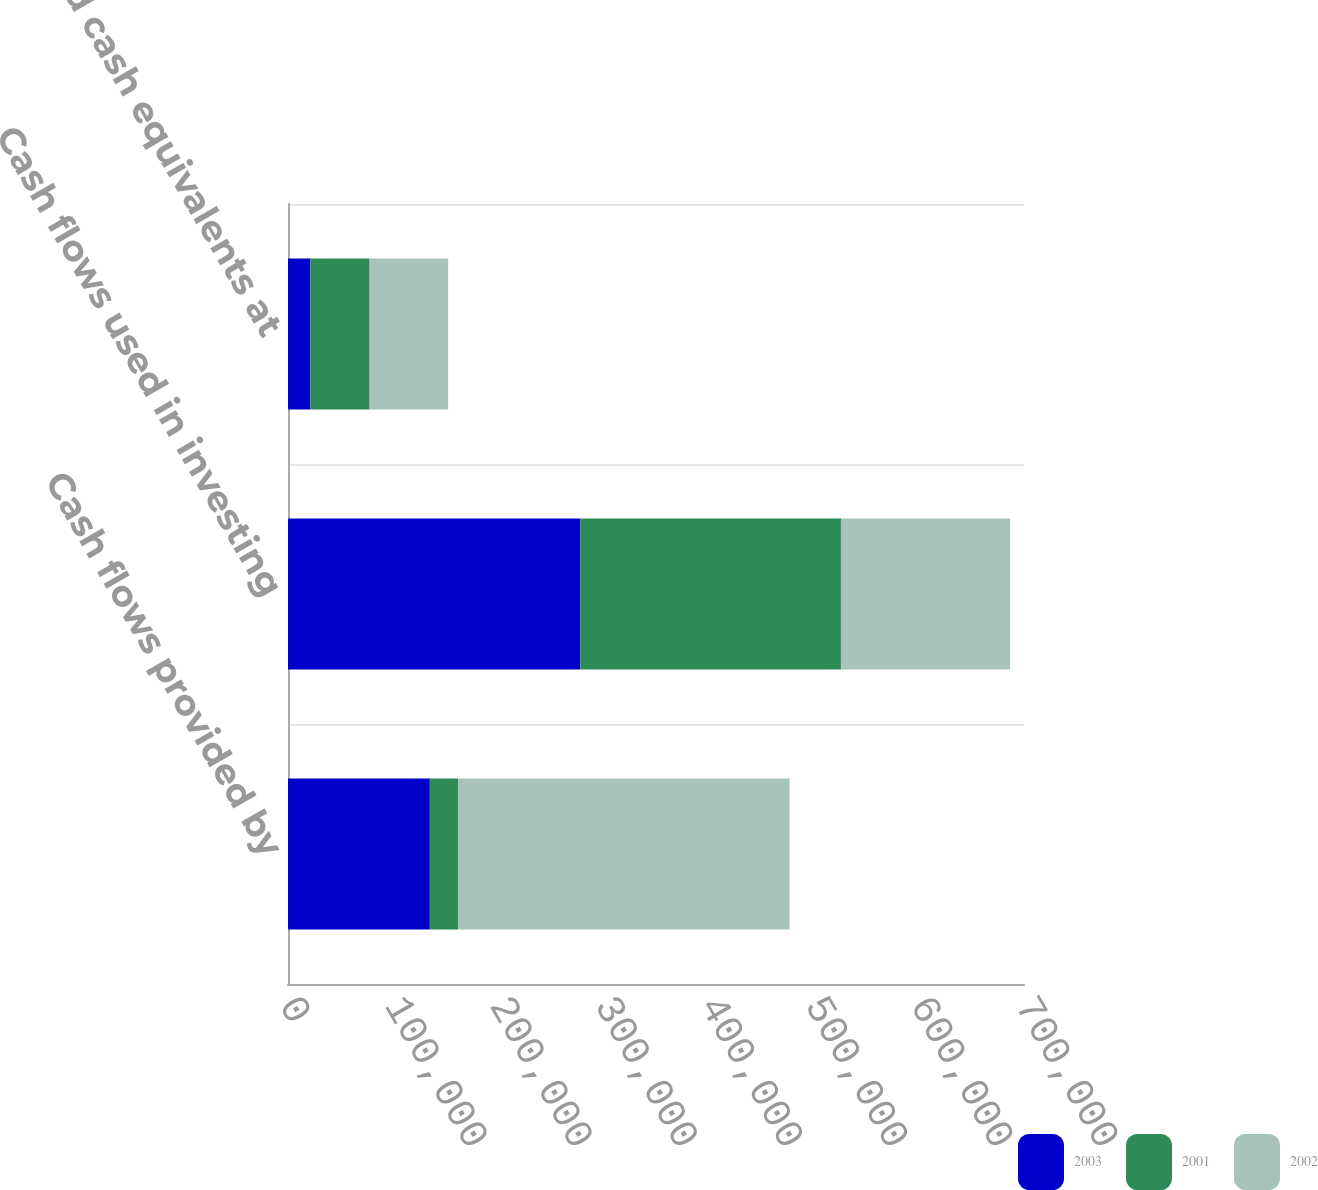Convert chart to OTSL. <chart><loc_0><loc_0><loc_500><loc_500><stacked_bar_chart><ecel><fcel>Cash flows provided by<fcel>Cash flows used in investing<fcel>Cash and cash equivalents at<nl><fcel>2003<fcel>134901<fcel>278136<fcel>21359<nl><fcel>2001<fcel>27098<fcel>247757<fcel>56292<nl><fcel>2002<fcel>315054<fcel>160909<fcel>74683<nl></chart> 